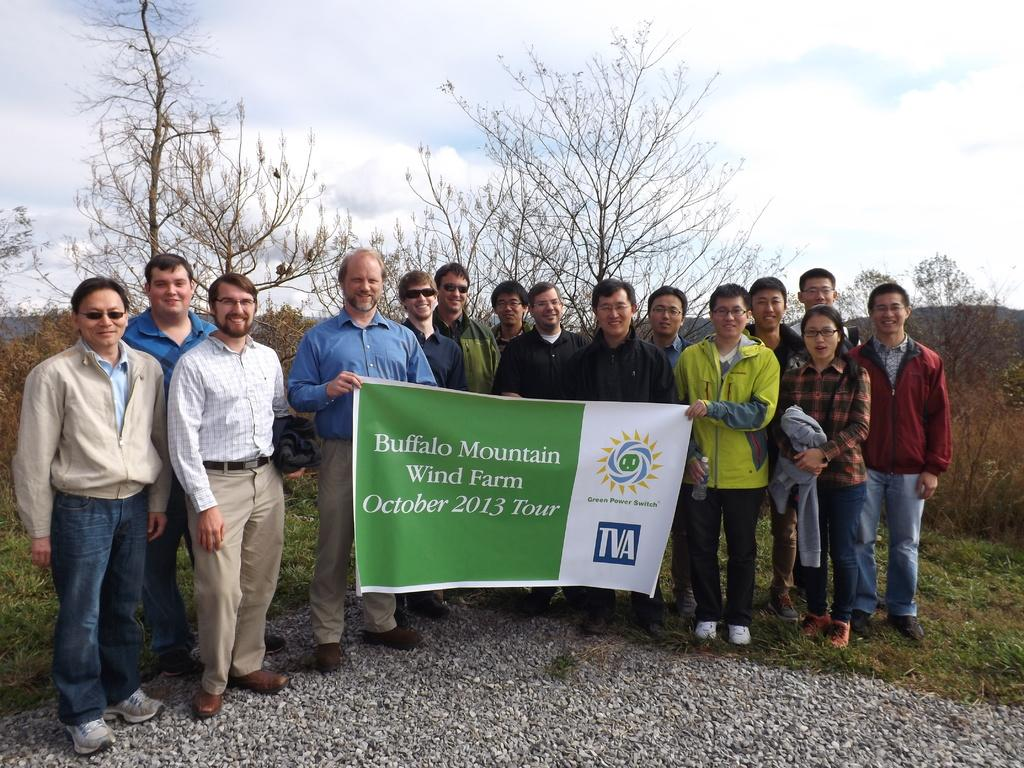What are the people in the image doing? The people in the image are standing and holding a board. What can be seen at the bottom of the image? There are stones and grass at the bottom of the image. What is visible in the background of the image? There are trees and the sky visible in the background of the image. What type of nerve can be seen hanging from the tree in the image? There is no nerve visible in the image, and no tree is mentioned in the provided facts. What topic are the people discussing in the image? The provided facts do not mention any discussion or conversation among the people in the image. 